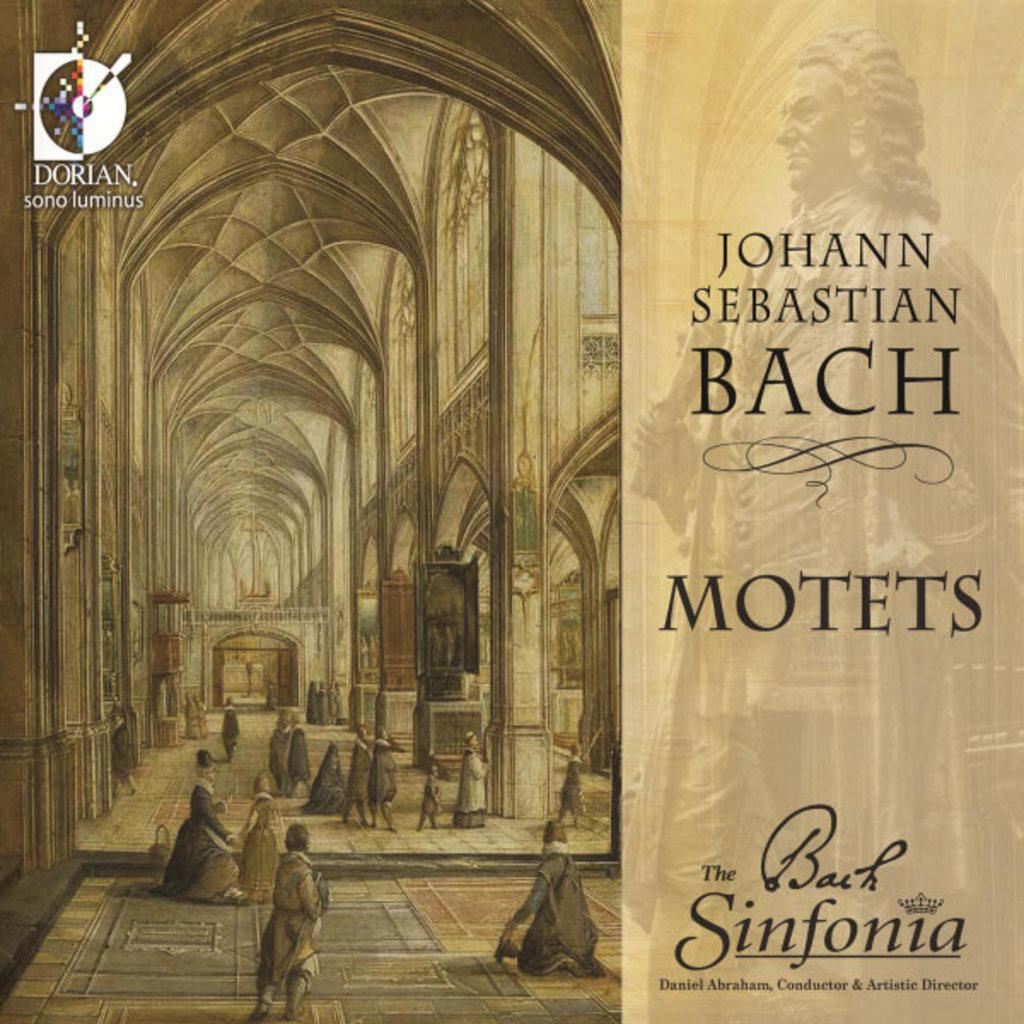<image>
Create a compact narrative representing the image presented. A drawing of a cathedral says Johann Sebastian Bach Motets. 